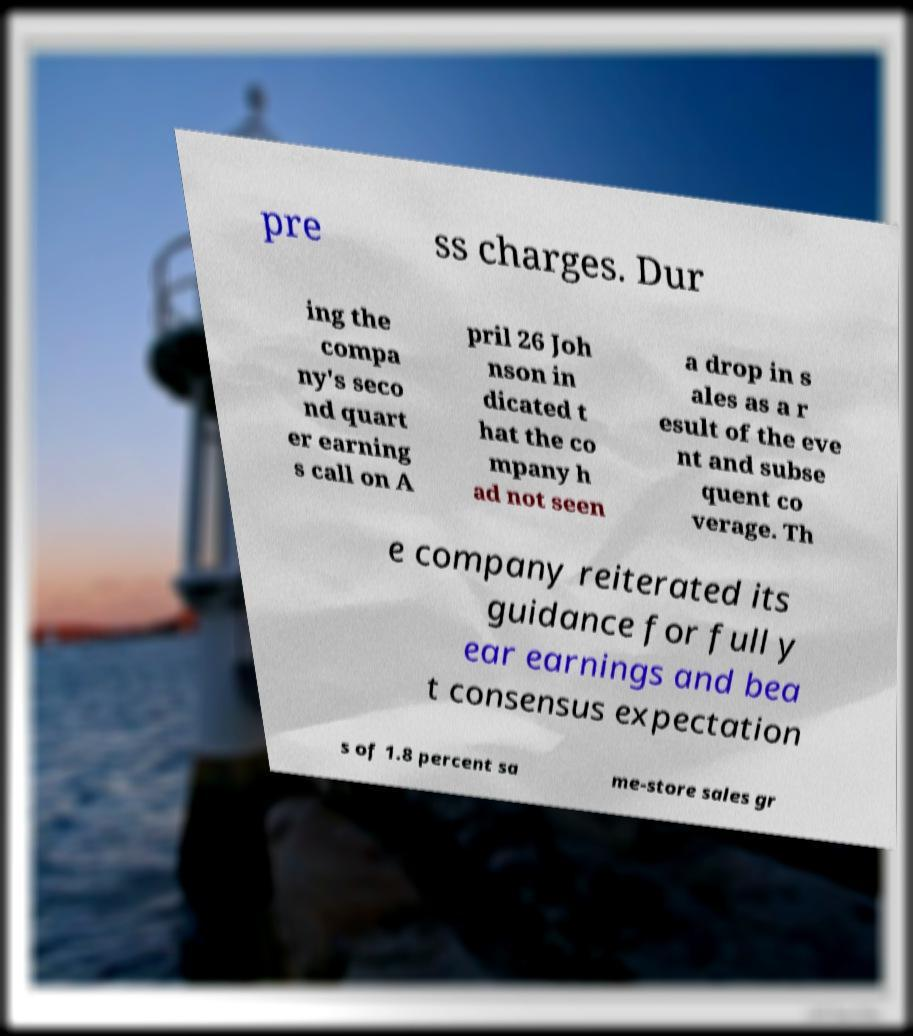There's text embedded in this image that I need extracted. Can you transcribe it verbatim? pre ss charges. Dur ing the compa ny's seco nd quart er earning s call on A pril 26 Joh nson in dicated t hat the co mpany h ad not seen a drop in s ales as a r esult of the eve nt and subse quent co verage. Th e company reiterated its guidance for full y ear earnings and bea t consensus expectation s of 1.8 percent sa me-store sales gr 